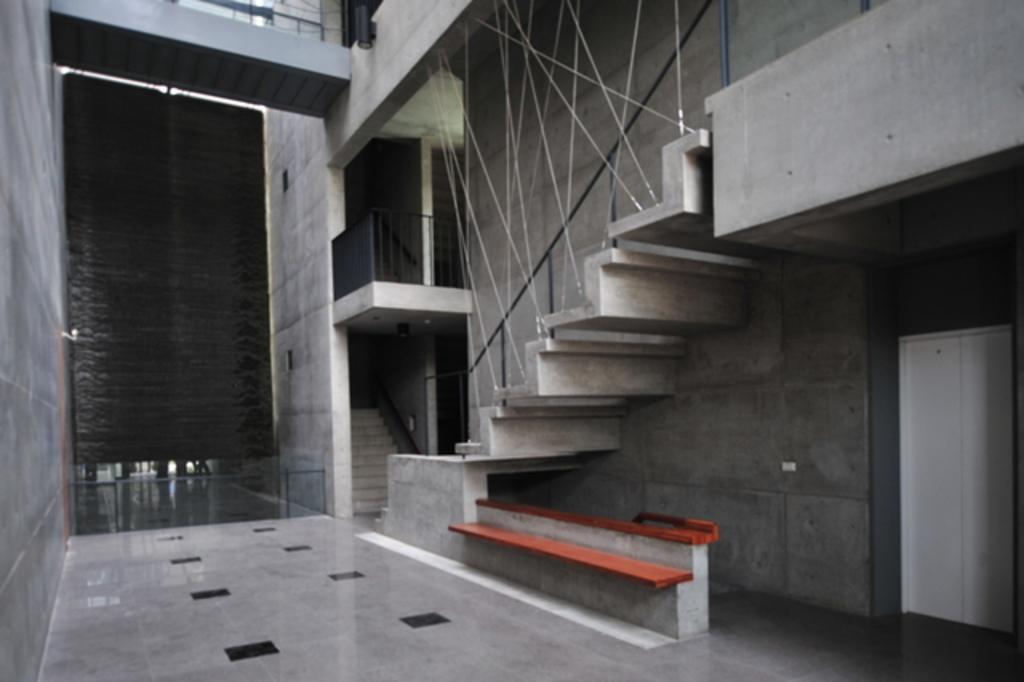Could you give a brief overview of what you see in this image? In this image we can see doors, staircases, poles, grille and the wall, also we can see the floor and a bench. 